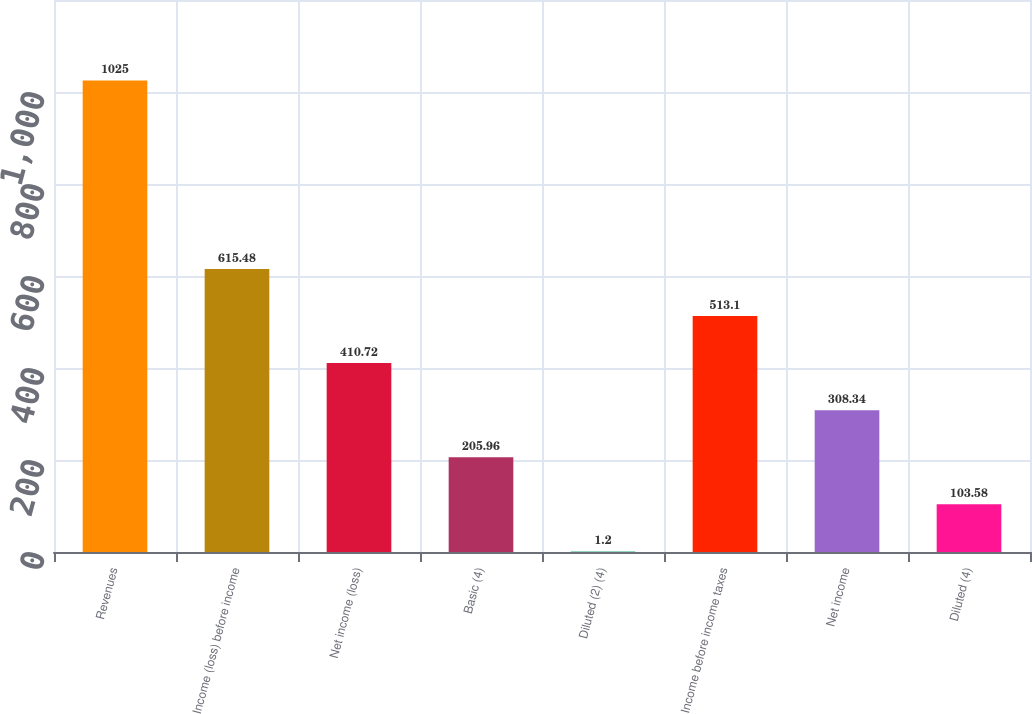Convert chart to OTSL. <chart><loc_0><loc_0><loc_500><loc_500><bar_chart><fcel>Revenues<fcel>Income (loss) before income<fcel>Net income (loss)<fcel>Basic (4)<fcel>Diluted (2) (4)<fcel>Income before income taxes<fcel>Net income<fcel>Diluted (4)<nl><fcel>1025<fcel>615.48<fcel>410.72<fcel>205.96<fcel>1.2<fcel>513.1<fcel>308.34<fcel>103.58<nl></chart> 